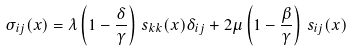Convert formula to latex. <formula><loc_0><loc_0><loc_500><loc_500>\sigma _ { i j } ( { x } ) = \lambda \left ( 1 - \frac { \delta } { \gamma } \right ) \, s _ { k k } ( { x } ) \delta _ { i j } + 2 \mu \left ( 1 - \frac { \beta } { \gamma } \right ) \, s _ { i j } ( { x } )</formula> 